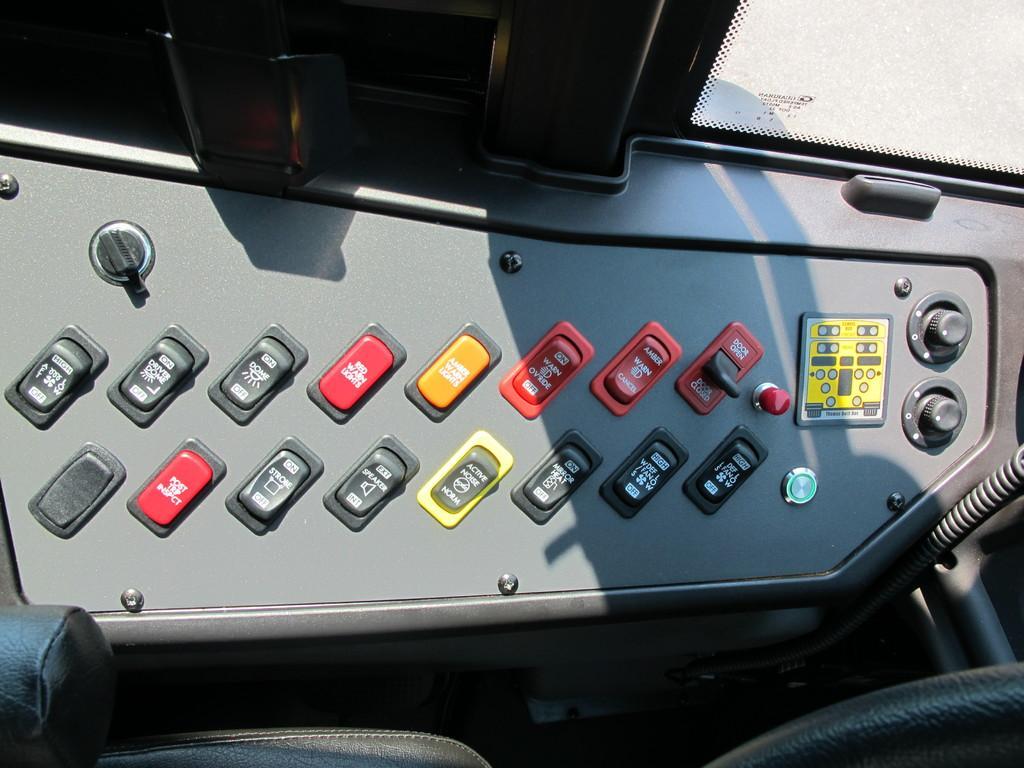Describe this image in one or two sentences. In this picture I can see there is a bus control panel and it has different buttons and they are in red and yellow colors. 